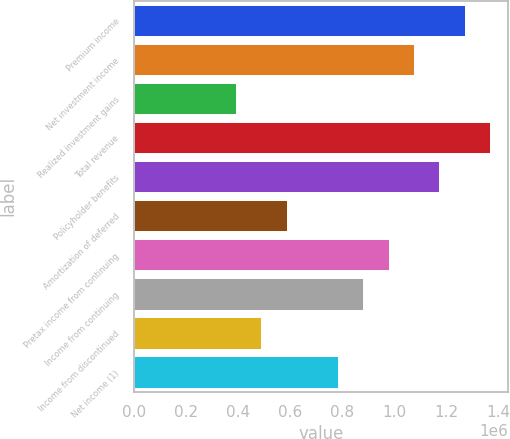Convert chart to OTSL. <chart><loc_0><loc_0><loc_500><loc_500><bar_chart><fcel>Premium income<fcel>Net investment income<fcel>Realized investment gains<fcel>Total revenue<fcel>Policyholder benefits<fcel>Amortization of deferred<fcel>Pretax income from continuing<fcel>Income from continuing<fcel>Income from discontinued<fcel>Net income (1)<nl><fcel>1.27092e+06<fcel>1.07539e+06<fcel>391051<fcel>1.36868e+06<fcel>1.17315e+06<fcel>586576<fcel>977627<fcel>879864<fcel>488814<fcel>782102<nl></chart> 